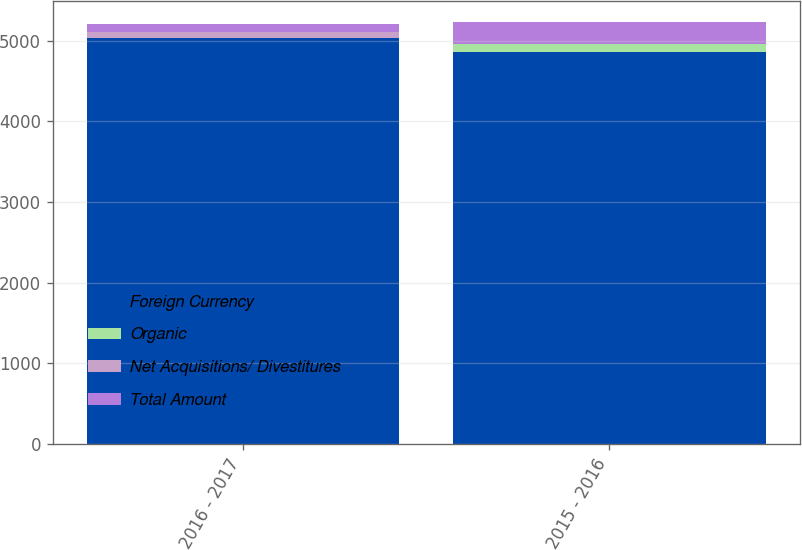<chart> <loc_0><loc_0><loc_500><loc_500><stacked_bar_chart><ecel><fcel>2016 - 2017<fcel>2015 - 2016<nl><fcel>Foreign Currency<fcel>5035.1<fcel>4854.8<nl><fcel>Organic<fcel>4.1<fcel>99.7<nl><fcel>Net Acquisitions/ Divestitures<fcel>65.2<fcel>2.2<nl><fcel>Total Amount<fcel>102.3<fcel>277.8<nl></chart> 